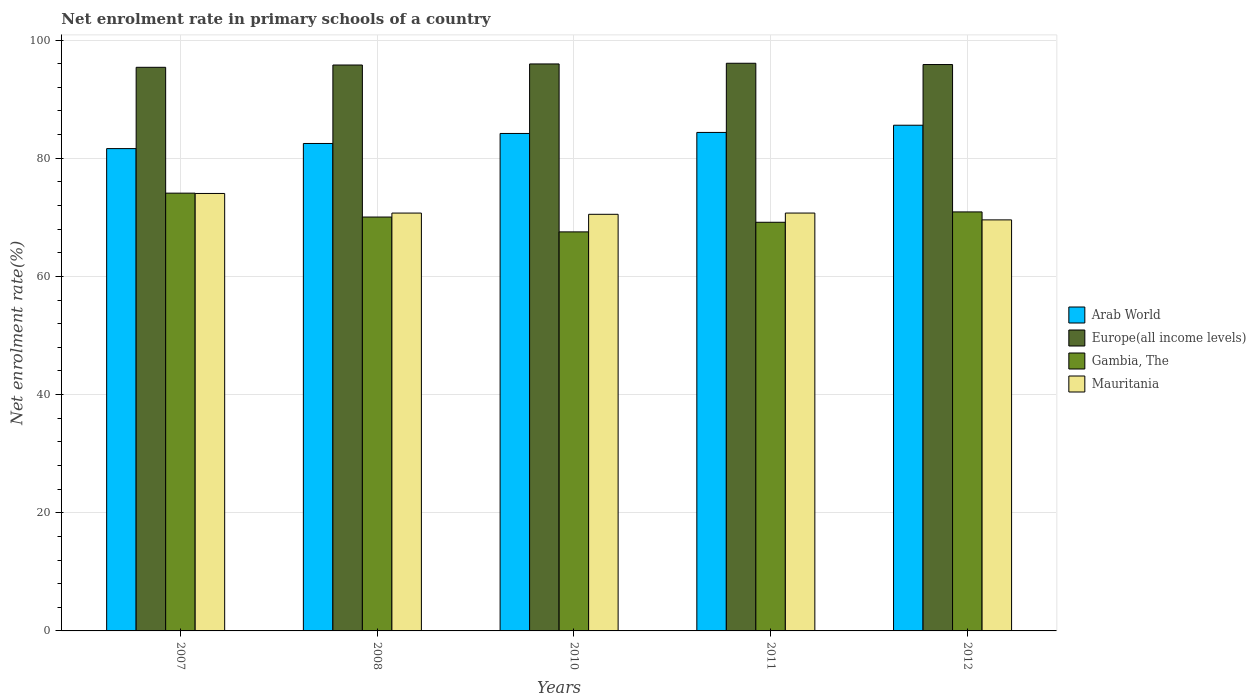How many different coloured bars are there?
Your answer should be compact. 4. How many groups of bars are there?
Your answer should be very brief. 5. Are the number of bars on each tick of the X-axis equal?
Give a very brief answer. Yes. How many bars are there on the 5th tick from the left?
Your answer should be compact. 4. How many bars are there on the 4th tick from the right?
Provide a succinct answer. 4. What is the net enrolment rate in primary schools in Mauritania in 2012?
Your answer should be very brief. 69.56. Across all years, what is the maximum net enrolment rate in primary schools in Gambia, The?
Give a very brief answer. 74.09. Across all years, what is the minimum net enrolment rate in primary schools in Arab World?
Provide a short and direct response. 81.63. In which year was the net enrolment rate in primary schools in Mauritania minimum?
Offer a terse response. 2012. What is the total net enrolment rate in primary schools in Europe(all income levels) in the graph?
Give a very brief answer. 479.04. What is the difference between the net enrolment rate in primary schools in Europe(all income levels) in 2011 and that in 2012?
Give a very brief answer. 0.22. What is the difference between the net enrolment rate in primary schools in Mauritania in 2007 and the net enrolment rate in primary schools in Gambia, The in 2010?
Give a very brief answer. 6.5. What is the average net enrolment rate in primary schools in Mauritania per year?
Your answer should be compact. 71.11. In the year 2011, what is the difference between the net enrolment rate in primary schools in Mauritania and net enrolment rate in primary schools in Europe(all income levels)?
Ensure brevity in your answer.  -25.35. What is the ratio of the net enrolment rate in primary schools in Mauritania in 2010 to that in 2011?
Offer a very short reply. 1. Is the difference between the net enrolment rate in primary schools in Mauritania in 2008 and 2010 greater than the difference between the net enrolment rate in primary schools in Europe(all income levels) in 2008 and 2010?
Your answer should be very brief. Yes. What is the difference between the highest and the second highest net enrolment rate in primary schools in Mauritania?
Ensure brevity in your answer.  3.32. What is the difference between the highest and the lowest net enrolment rate in primary schools in Mauritania?
Provide a succinct answer. 4.47. Is it the case that in every year, the sum of the net enrolment rate in primary schools in Arab World and net enrolment rate in primary schools in Gambia, The is greater than the sum of net enrolment rate in primary schools in Europe(all income levels) and net enrolment rate in primary schools in Mauritania?
Ensure brevity in your answer.  No. What does the 3rd bar from the left in 2010 represents?
Keep it short and to the point. Gambia, The. What does the 2nd bar from the right in 2010 represents?
Your answer should be compact. Gambia, The. Is it the case that in every year, the sum of the net enrolment rate in primary schools in Arab World and net enrolment rate in primary schools in Gambia, The is greater than the net enrolment rate in primary schools in Mauritania?
Ensure brevity in your answer.  Yes. How many bars are there?
Your answer should be very brief. 20. Are all the bars in the graph horizontal?
Your answer should be compact. No. How many years are there in the graph?
Make the answer very short. 5. What is the difference between two consecutive major ticks on the Y-axis?
Offer a very short reply. 20. Are the values on the major ticks of Y-axis written in scientific E-notation?
Ensure brevity in your answer.  No. Does the graph contain grids?
Offer a terse response. Yes. Where does the legend appear in the graph?
Offer a very short reply. Center right. How many legend labels are there?
Offer a terse response. 4. What is the title of the graph?
Make the answer very short. Net enrolment rate in primary schools of a country. Does "Oman" appear as one of the legend labels in the graph?
Offer a terse response. No. What is the label or title of the Y-axis?
Ensure brevity in your answer.  Net enrolment rate(%). What is the Net enrolment rate(%) in Arab World in 2007?
Make the answer very short. 81.63. What is the Net enrolment rate(%) in Europe(all income levels) in 2007?
Your answer should be compact. 95.39. What is the Net enrolment rate(%) of Gambia, The in 2007?
Ensure brevity in your answer.  74.09. What is the Net enrolment rate(%) in Mauritania in 2007?
Provide a succinct answer. 74.04. What is the Net enrolment rate(%) in Arab World in 2008?
Provide a short and direct response. 82.5. What is the Net enrolment rate(%) in Europe(all income levels) in 2008?
Your answer should be compact. 95.77. What is the Net enrolment rate(%) in Gambia, The in 2008?
Your answer should be very brief. 70.05. What is the Net enrolment rate(%) in Mauritania in 2008?
Provide a short and direct response. 70.72. What is the Net enrolment rate(%) in Arab World in 2010?
Make the answer very short. 84.19. What is the Net enrolment rate(%) in Europe(all income levels) in 2010?
Provide a short and direct response. 95.95. What is the Net enrolment rate(%) in Gambia, The in 2010?
Your answer should be very brief. 67.53. What is the Net enrolment rate(%) in Mauritania in 2010?
Your answer should be very brief. 70.51. What is the Net enrolment rate(%) of Arab World in 2011?
Provide a succinct answer. 84.36. What is the Net enrolment rate(%) of Europe(all income levels) in 2011?
Your answer should be very brief. 96.07. What is the Net enrolment rate(%) in Gambia, The in 2011?
Offer a very short reply. 69.16. What is the Net enrolment rate(%) in Mauritania in 2011?
Provide a short and direct response. 70.72. What is the Net enrolment rate(%) of Arab World in 2012?
Make the answer very short. 85.59. What is the Net enrolment rate(%) in Europe(all income levels) in 2012?
Your response must be concise. 95.85. What is the Net enrolment rate(%) of Gambia, The in 2012?
Your response must be concise. 70.91. What is the Net enrolment rate(%) in Mauritania in 2012?
Offer a very short reply. 69.56. Across all years, what is the maximum Net enrolment rate(%) of Arab World?
Keep it short and to the point. 85.59. Across all years, what is the maximum Net enrolment rate(%) of Europe(all income levels)?
Offer a very short reply. 96.07. Across all years, what is the maximum Net enrolment rate(%) in Gambia, The?
Offer a very short reply. 74.09. Across all years, what is the maximum Net enrolment rate(%) in Mauritania?
Offer a very short reply. 74.04. Across all years, what is the minimum Net enrolment rate(%) in Arab World?
Keep it short and to the point. 81.63. Across all years, what is the minimum Net enrolment rate(%) of Europe(all income levels)?
Give a very brief answer. 95.39. Across all years, what is the minimum Net enrolment rate(%) in Gambia, The?
Offer a very short reply. 67.53. Across all years, what is the minimum Net enrolment rate(%) of Mauritania?
Give a very brief answer. 69.56. What is the total Net enrolment rate(%) of Arab World in the graph?
Your answer should be compact. 418.26. What is the total Net enrolment rate(%) in Europe(all income levels) in the graph?
Your answer should be compact. 479.04. What is the total Net enrolment rate(%) in Gambia, The in the graph?
Your answer should be compact. 351.74. What is the total Net enrolment rate(%) in Mauritania in the graph?
Your answer should be very brief. 355.55. What is the difference between the Net enrolment rate(%) in Arab World in 2007 and that in 2008?
Your response must be concise. -0.87. What is the difference between the Net enrolment rate(%) of Europe(all income levels) in 2007 and that in 2008?
Provide a short and direct response. -0.39. What is the difference between the Net enrolment rate(%) in Gambia, The in 2007 and that in 2008?
Keep it short and to the point. 4.04. What is the difference between the Net enrolment rate(%) of Mauritania in 2007 and that in 2008?
Your answer should be compact. 3.32. What is the difference between the Net enrolment rate(%) in Arab World in 2007 and that in 2010?
Give a very brief answer. -2.56. What is the difference between the Net enrolment rate(%) of Europe(all income levels) in 2007 and that in 2010?
Your answer should be very brief. -0.57. What is the difference between the Net enrolment rate(%) in Gambia, The in 2007 and that in 2010?
Provide a succinct answer. 6.56. What is the difference between the Net enrolment rate(%) in Mauritania in 2007 and that in 2010?
Give a very brief answer. 3.53. What is the difference between the Net enrolment rate(%) in Arab World in 2007 and that in 2011?
Keep it short and to the point. -2.74. What is the difference between the Net enrolment rate(%) of Europe(all income levels) in 2007 and that in 2011?
Offer a terse response. -0.68. What is the difference between the Net enrolment rate(%) in Gambia, The in 2007 and that in 2011?
Offer a very short reply. 4.93. What is the difference between the Net enrolment rate(%) of Mauritania in 2007 and that in 2011?
Offer a very short reply. 3.32. What is the difference between the Net enrolment rate(%) of Arab World in 2007 and that in 2012?
Your response must be concise. -3.96. What is the difference between the Net enrolment rate(%) in Europe(all income levels) in 2007 and that in 2012?
Your answer should be very brief. -0.47. What is the difference between the Net enrolment rate(%) in Gambia, The in 2007 and that in 2012?
Your response must be concise. 3.18. What is the difference between the Net enrolment rate(%) in Mauritania in 2007 and that in 2012?
Ensure brevity in your answer.  4.47. What is the difference between the Net enrolment rate(%) in Arab World in 2008 and that in 2010?
Your answer should be compact. -1.69. What is the difference between the Net enrolment rate(%) of Europe(all income levels) in 2008 and that in 2010?
Provide a short and direct response. -0.18. What is the difference between the Net enrolment rate(%) in Gambia, The in 2008 and that in 2010?
Your answer should be very brief. 2.51. What is the difference between the Net enrolment rate(%) of Mauritania in 2008 and that in 2010?
Provide a short and direct response. 0.21. What is the difference between the Net enrolment rate(%) in Arab World in 2008 and that in 2011?
Your answer should be very brief. -1.87. What is the difference between the Net enrolment rate(%) in Europe(all income levels) in 2008 and that in 2011?
Your response must be concise. -0.3. What is the difference between the Net enrolment rate(%) of Gambia, The in 2008 and that in 2011?
Offer a terse response. 0.89. What is the difference between the Net enrolment rate(%) of Mauritania in 2008 and that in 2011?
Your answer should be compact. -0. What is the difference between the Net enrolment rate(%) in Arab World in 2008 and that in 2012?
Offer a terse response. -3.09. What is the difference between the Net enrolment rate(%) in Europe(all income levels) in 2008 and that in 2012?
Offer a very short reply. -0.08. What is the difference between the Net enrolment rate(%) of Gambia, The in 2008 and that in 2012?
Your answer should be very brief. -0.87. What is the difference between the Net enrolment rate(%) of Mauritania in 2008 and that in 2012?
Keep it short and to the point. 1.15. What is the difference between the Net enrolment rate(%) of Arab World in 2010 and that in 2011?
Provide a short and direct response. -0.17. What is the difference between the Net enrolment rate(%) in Europe(all income levels) in 2010 and that in 2011?
Your answer should be very brief. -0.12. What is the difference between the Net enrolment rate(%) of Gambia, The in 2010 and that in 2011?
Your answer should be compact. -1.63. What is the difference between the Net enrolment rate(%) of Mauritania in 2010 and that in 2011?
Provide a succinct answer. -0.21. What is the difference between the Net enrolment rate(%) in Arab World in 2010 and that in 2012?
Make the answer very short. -1.4. What is the difference between the Net enrolment rate(%) in Europe(all income levels) in 2010 and that in 2012?
Make the answer very short. 0.1. What is the difference between the Net enrolment rate(%) in Gambia, The in 2010 and that in 2012?
Offer a terse response. -3.38. What is the difference between the Net enrolment rate(%) of Mauritania in 2010 and that in 2012?
Offer a terse response. 0.94. What is the difference between the Net enrolment rate(%) of Arab World in 2011 and that in 2012?
Ensure brevity in your answer.  -1.22. What is the difference between the Net enrolment rate(%) in Europe(all income levels) in 2011 and that in 2012?
Offer a terse response. 0.22. What is the difference between the Net enrolment rate(%) in Gambia, The in 2011 and that in 2012?
Offer a very short reply. -1.75. What is the difference between the Net enrolment rate(%) in Mauritania in 2011 and that in 2012?
Give a very brief answer. 1.15. What is the difference between the Net enrolment rate(%) in Arab World in 2007 and the Net enrolment rate(%) in Europe(all income levels) in 2008?
Provide a short and direct response. -14.15. What is the difference between the Net enrolment rate(%) of Arab World in 2007 and the Net enrolment rate(%) of Gambia, The in 2008?
Your answer should be very brief. 11.58. What is the difference between the Net enrolment rate(%) in Arab World in 2007 and the Net enrolment rate(%) in Mauritania in 2008?
Keep it short and to the point. 10.91. What is the difference between the Net enrolment rate(%) in Europe(all income levels) in 2007 and the Net enrolment rate(%) in Gambia, The in 2008?
Give a very brief answer. 25.34. What is the difference between the Net enrolment rate(%) in Europe(all income levels) in 2007 and the Net enrolment rate(%) in Mauritania in 2008?
Make the answer very short. 24.67. What is the difference between the Net enrolment rate(%) in Gambia, The in 2007 and the Net enrolment rate(%) in Mauritania in 2008?
Provide a short and direct response. 3.37. What is the difference between the Net enrolment rate(%) of Arab World in 2007 and the Net enrolment rate(%) of Europe(all income levels) in 2010?
Offer a very short reply. -14.33. What is the difference between the Net enrolment rate(%) in Arab World in 2007 and the Net enrolment rate(%) in Gambia, The in 2010?
Offer a very short reply. 14.09. What is the difference between the Net enrolment rate(%) in Arab World in 2007 and the Net enrolment rate(%) in Mauritania in 2010?
Your answer should be very brief. 11.12. What is the difference between the Net enrolment rate(%) of Europe(all income levels) in 2007 and the Net enrolment rate(%) of Gambia, The in 2010?
Provide a succinct answer. 27.86. What is the difference between the Net enrolment rate(%) in Europe(all income levels) in 2007 and the Net enrolment rate(%) in Mauritania in 2010?
Ensure brevity in your answer.  24.88. What is the difference between the Net enrolment rate(%) in Gambia, The in 2007 and the Net enrolment rate(%) in Mauritania in 2010?
Your response must be concise. 3.58. What is the difference between the Net enrolment rate(%) in Arab World in 2007 and the Net enrolment rate(%) in Europe(all income levels) in 2011?
Your answer should be compact. -14.44. What is the difference between the Net enrolment rate(%) of Arab World in 2007 and the Net enrolment rate(%) of Gambia, The in 2011?
Offer a very short reply. 12.47. What is the difference between the Net enrolment rate(%) of Arab World in 2007 and the Net enrolment rate(%) of Mauritania in 2011?
Provide a short and direct response. 10.91. What is the difference between the Net enrolment rate(%) in Europe(all income levels) in 2007 and the Net enrolment rate(%) in Gambia, The in 2011?
Provide a short and direct response. 26.23. What is the difference between the Net enrolment rate(%) in Europe(all income levels) in 2007 and the Net enrolment rate(%) in Mauritania in 2011?
Ensure brevity in your answer.  24.67. What is the difference between the Net enrolment rate(%) in Gambia, The in 2007 and the Net enrolment rate(%) in Mauritania in 2011?
Make the answer very short. 3.37. What is the difference between the Net enrolment rate(%) of Arab World in 2007 and the Net enrolment rate(%) of Europe(all income levels) in 2012?
Your answer should be very brief. -14.23. What is the difference between the Net enrolment rate(%) of Arab World in 2007 and the Net enrolment rate(%) of Gambia, The in 2012?
Provide a succinct answer. 10.71. What is the difference between the Net enrolment rate(%) in Arab World in 2007 and the Net enrolment rate(%) in Mauritania in 2012?
Offer a terse response. 12.06. What is the difference between the Net enrolment rate(%) of Europe(all income levels) in 2007 and the Net enrolment rate(%) of Gambia, The in 2012?
Ensure brevity in your answer.  24.48. What is the difference between the Net enrolment rate(%) of Europe(all income levels) in 2007 and the Net enrolment rate(%) of Mauritania in 2012?
Keep it short and to the point. 25.82. What is the difference between the Net enrolment rate(%) of Gambia, The in 2007 and the Net enrolment rate(%) of Mauritania in 2012?
Your response must be concise. 4.53. What is the difference between the Net enrolment rate(%) in Arab World in 2008 and the Net enrolment rate(%) in Europe(all income levels) in 2010?
Your answer should be compact. -13.46. What is the difference between the Net enrolment rate(%) in Arab World in 2008 and the Net enrolment rate(%) in Gambia, The in 2010?
Give a very brief answer. 14.96. What is the difference between the Net enrolment rate(%) of Arab World in 2008 and the Net enrolment rate(%) of Mauritania in 2010?
Your response must be concise. 11.99. What is the difference between the Net enrolment rate(%) in Europe(all income levels) in 2008 and the Net enrolment rate(%) in Gambia, The in 2010?
Keep it short and to the point. 28.24. What is the difference between the Net enrolment rate(%) of Europe(all income levels) in 2008 and the Net enrolment rate(%) of Mauritania in 2010?
Ensure brevity in your answer.  25.27. What is the difference between the Net enrolment rate(%) in Gambia, The in 2008 and the Net enrolment rate(%) in Mauritania in 2010?
Your answer should be very brief. -0.46. What is the difference between the Net enrolment rate(%) of Arab World in 2008 and the Net enrolment rate(%) of Europe(all income levels) in 2011?
Offer a very short reply. -13.58. What is the difference between the Net enrolment rate(%) in Arab World in 2008 and the Net enrolment rate(%) in Gambia, The in 2011?
Give a very brief answer. 13.34. What is the difference between the Net enrolment rate(%) of Arab World in 2008 and the Net enrolment rate(%) of Mauritania in 2011?
Your response must be concise. 11.78. What is the difference between the Net enrolment rate(%) in Europe(all income levels) in 2008 and the Net enrolment rate(%) in Gambia, The in 2011?
Provide a short and direct response. 26.62. What is the difference between the Net enrolment rate(%) in Europe(all income levels) in 2008 and the Net enrolment rate(%) in Mauritania in 2011?
Your response must be concise. 25.06. What is the difference between the Net enrolment rate(%) of Gambia, The in 2008 and the Net enrolment rate(%) of Mauritania in 2011?
Offer a terse response. -0.67. What is the difference between the Net enrolment rate(%) of Arab World in 2008 and the Net enrolment rate(%) of Europe(all income levels) in 2012?
Ensure brevity in your answer.  -13.36. What is the difference between the Net enrolment rate(%) of Arab World in 2008 and the Net enrolment rate(%) of Gambia, The in 2012?
Provide a succinct answer. 11.58. What is the difference between the Net enrolment rate(%) in Arab World in 2008 and the Net enrolment rate(%) in Mauritania in 2012?
Ensure brevity in your answer.  12.93. What is the difference between the Net enrolment rate(%) of Europe(all income levels) in 2008 and the Net enrolment rate(%) of Gambia, The in 2012?
Provide a succinct answer. 24.86. What is the difference between the Net enrolment rate(%) in Europe(all income levels) in 2008 and the Net enrolment rate(%) in Mauritania in 2012?
Your response must be concise. 26.21. What is the difference between the Net enrolment rate(%) of Gambia, The in 2008 and the Net enrolment rate(%) of Mauritania in 2012?
Make the answer very short. 0.48. What is the difference between the Net enrolment rate(%) in Arab World in 2010 and the Net enrolment rate(%) in Europe(all income levels) in 2011?
Your response must be concise. -11.88. What is the difference between the Net enrolment rate(%) of Arab World in 2010 and the Net enrolment rate(%) of Gambia, The in 2011?
Keep it short and to the point. 15.03. What is the difference between the Net enrolment rate(%) in Arab World in 2010 and the Net enrolment rate(%) in Mauritania in 2011?
Provide a succinct answer. 13.47. What is the difference between the Net enrolment rate(%) of Europe(all income levels) in 2010 and the Net enrolment rate(%) of Gambia, The in 2011?
Your answer should be very brief. 26.8. What is the difference between the Net enrolment rate(%) of Europe(all income levels) in 2010 and the Net enrolment rate(%) of Mauritania in 2011?
Make the answer very short. 25.24. What is the difference between the Net enrolment rate(%) of Gambia, The in 2010 and the Net enrolment rate(%) of Mauritania in 2011?
Your answer should be very brief. -3.19. What is the difference between the Net enrolment rate(%) of Arab World in 2010 and the Net enrolment rate(%) of Europe(all income levels) in 2012?
Offer a very short reply. -11.66. What is the difference between the Net enrolment rate(%) in Arab World in 2010 and the Net enrolment rate(%) in Gambia, The in 2012?
Make the answer very short. 13.28. What is the difference between the Net enrolment rate(%) in Arab World in 2010 and the Net enrolment rate(%) in Mauritania in 2012?
Provide a succinct answer. 14.63. What is the difference between the Net enrolment rate(%) in Europe(all income levels) in 2010 and the Net enrolment rate(%) in Gambia, The in 2012?
Make the answer very short. 25.04. What is the difference between the Net enrolment rate(%) in Europe(all income levels) in 2010 and the Net enrolment rate(%) in Mauritania in 2012?
Make the answer very short. 26.39. What is the difference between the Net enrolment rate(%) of Gambia, The in 2010 and the Net enrolment rate(%) of Mauritania in 2012?
Keep it short and to the point. -2.03. What is the difference between the Net enrolment rate(%) in Arab World in 2011 and the Net enrolment rate(%) in Europe(all income levels) in 2012?
Give a very brief answer. -11.49. What is the difference between the Net enrolment rate(%) of Arab World in 2011 and the Net enrolment rate(%) of Gambia, The in 2012?
Offer a terse response. 13.45. What is the difference between the Net enrolment rate(%) of Arab World in 2011 and the Net enrolment rate(%) of Mauritania in 2012?
Your answer should be compact. 14.8. What is the difference between the Net enrolment rate(%) in Europe(all income levels) in 2011 and the Net enrolment rate(%) in Gambia, The in 2012?
Make the answer very short. 25.16. What is the difference between the Net enrolment rate(%) in Europe(all income levels) in 2011 and the Net enrolment rate(%) in Mauritania in 2012?
Offer a terse response. 26.51. What is the difference between the Net enrolment rate(%) of Gambia, The in 2011 and the Net enrolment rate(%) of Mauritania in 2012?
Provide a short and direct response. -0.41. What is the average Net enrolment rate(%) in Arab World per year?
Ensure brevity in your answer.  83.65. What is the average Net enrolment rate(%) of Europe(all income levels) per year?
Give a very brief answer. 95.81. What is the average Net enrolment rate(%) of Gambia, The per year?
Your response must be concise. 70.35. What is the average Net enrolment rate(%) in Mauritania per year?
Offer a terse response. 71.11. In the year 2007, what is the difference between the Net enrolment rate(%) of Arab World and Net enrolment rate(%) of Europe(all income levels)?
Provide a short and direct response. -13.76. In the year 2007, what is the difference between the Net enrolment rate(%) in Arab World and Net enrolment rate(%) in Gambia, The?
Your answer should be compact. 7.54. In the year 2007, what is the difference between the Net enrolment rate(%) in Arab World and Net enrolment rate(%) in Mauritania?
Keep it short and to the point. 7.59. In the year 2007, what is the difference between the Net enrolment rate(%) in Europe(all income levels) and Net enrolment rate(%) in Gambia, The?
Your answer should be very brief. 21.3. In the year 2007, what is the difference between the Net enrolment rate(%) of Europe(all income levels) and Net enrolment rate(%) of Mauritania?
Your answer should be very brief. 21.35. In the year 2007, what is the difference between the Net enrolment rate(%) of Gambia, The and Net enrolment rate(%) of Mauritania?
Keep it short and to the point. 0.05. In the year 2008, what is the difference between the Net enrolment rate(%) in Arab World and Net enrolment rate(%) in Europe(all income levels)?
Keep it short and to the point. -13.28. In the year 2008, what is the difference between the Net enrolment rate(%) of Arab World and Net enrolment rate(%) of Gambia, The?
Provide a succinct answer. 12.45. In the year 2008, what is the difference between the Net enrolment rate(%) of Arab World and Net enrolment rate(%) of Mauritania?
Make the answer very short. 11.78. In the year 2008, what is the difference between the Net enrolment rate(%) of Europe(all income levels) and Net enrolment rate(%) of Gambia, The?
Ensure brevity in your answer.  25.73. In the year 2008, what is the difference between the Net enrolment rate(%) of Europe(all income levels) and Net enrolment rate(%) of Mauritania?
Keep it short and to the point. 25.06. In the year 2008, what is the difference between the Net enrolment rate(%) in Gambia, The and Net enrolment rate(%) in Mauritania?
Offer a very short reply. -0.67. In the year 2010, what is the difference between the Net enrolment rate(%) in Arab World and Net enrolment rate(%) in Europe(all income levels)?
Make the answer very short. -11.77. In the year 2010, what is the difference between the Net enrolment rate(%) in Arab World and Net enrolment rate(%) in Gambia, The?
Offer a terse response. 16.66. In the year 2010, what is the difference between the Net enrolment rate(%) in Arab World and Net enrolment rate(%) in Mauritania?
Provide a succinct answer. 13.68. In the year 2010, what is the difference between the Net enrolment rate(%) in Europe(all income levels) and Net enrolment rate(%) in Gambia, The?
Your response must be concise. 28.42. In the year 2010, what is the difference between the Net enrolment rate(%) of Europe(all income levels) and Net enrolment rate(%) of Mauritania?
Provide a succinct answer. 25.45. In the year 2010, what is the difference between the Net enrolment rate(%) in Gambia, The and Net enrolment rate(%) in Mauritania?
Your answer should be compact. -2.98. In the year 2011, what is the difference between the Net enrolment rate(%) of Arab World and Net enrolment rate(%) of Europe(all income levels)?
Offer a terse response. -11.71. In the year 2011, what is the difference between the Net enrolment rate(%) in Arab World and Net enrolment rate(%) in Gambia, The?
Make the answer very short. 15.21. In the year 2011, what is the difference between the Net enrolment rate(%) in Arab World and Net enrolment rate(%) in Mauritania?
Give a very brief answer. 13.65. In the year 2011, what is the difference between the Net enrolment rate(%) in Europe(all income levels) and Net enrolment rate(%) in Gambia, The?
Provide a short and direct response. 26.91. In the year 2011, what is the difference between the Net enrolment rate(%) in Europe(all income levels) and Net enrolment rate(%) in Mauritania?
Your answer should be very brief. 25.35. In the year 2011, what is the difference between the Net enrolment rate(%) in Gambia, The and Net enrolment rate(%) in Mauritania?
Your answer should be compact. -1.56. In the year 2012, what is the difference between the Net enrolment rate(%) in Arab World and Net enrolment rate(%) in Europe(all income levels)?
Keep it short and to the point. -10.27. In the year 2012, what is the difference between the Net enrolment rate(%) in Arab World and Net enrolment rate(%) in Gambia, The?
Your answer should be very brief. 14.67. In the year 2012, what is the difference between the Net enrolment rate(%) in Arab World and Net enrolment rate(%) in Mauritania?
Your answer should be very brief. 16.02. In the year 2012, what is the difference between the Net enrolment rate(%) of Europe(all income levels) and Net enrolment rate(%) of Gambia, The?
Give a very brief answer. 24.94. In the year 2012, what is the difference between the Net enrolment rate(%) of Europe(all income levels) and Net enrolment rate(%) of Mauritania?
Your response must be concise. 26.29. In the year 2012, what is the difference between the Net enrolment rate(%) in Gambia, The and Net enrolment rate(%) in Mauritania?
Make the answer very short. 1.35. What is the ratio of the Net enrolment rate(%) of Europe(all income levels) in 2007 to that in 2008?
Ensure brevity in your answer.  1. What is the ratio of the Net enrolment rate(%) in Gambia, The in 2007 to that in 2008?
Provide a succinct answer. 1.06. What is the ratio of the Net enrolment rate(%) of Mauritania in 2007 to that in 2008?
Provide a succinct answer. 1.05. What is the ratio of the Net enrolment rate(%) of Arab World in 2007 to that in 2010?
Offer a terse response. 0.97. What is the ratio of the Net enrolment rate(%) in Europe(all income levels) in 2007 to that in 2010?
Offer a terse response. 0.99. What is the ratio of the Net enrolment rate(%) in Gambia, The in 2007 to that in 2010?
Keep it short and to the point. 1.1. What is the ratio of the Net enrolment rate(%) in Arab World in 2007 to that in 2011?
Your answer should be compact. 0.97. What is the ratio of the Net enrolment rate(%) in Europe(all income levels) in 2007 to that in 2011?
Keep it short and to the point. 0.99. What is the ratio of the Net enrolment rate(%) in Gambia, The in 2007 to that in 2011?
Your answer should be compact. 1.07. What is the ratio of the Net enrolment rate(%) in Mauritania in 2007 to that in 2011?
Give a very brief answer. 1.05. What is the ratio of the Net enrolment rate(%) in Arab World in 2007 to that in 2012?
Provide a short and direct response. 0.95. What is the ratio of the Net enrolment rate(%) in Europe(all income levels) in 2007 to that in 2012?
Give a very brief answer. 1. What is the ratio of the Net enrolment rate(%) of Gambia, The in 2007 to that in 2012?
Your response must be concise. 1.04. What is the ratio of the Net enrolment rate(%) of Mauritania in 2007 to that in 2012?
Your answer should be very brief. 1.06. What is the ratio of the Net enrolment rate(%) in Arab World in 2008 to that in 2010?
Your answer should be very brief. 0.98. What is the ratio of the Net enrolment rate(%) of Gambia, The in 2008 to that in 2010?
Your response must be concise. 1.04. What is the ratio of the Net enrolment rate(%) of Mauritania in 2008 to that in 2010?
Give a very brief answer. 1. What is the ratio of the Net enrolment rate(%) in Arab World in 2008 to that in 2011?
Provide a short and direct response. 0.98. What is the ratio of the Net enrolment rate(%) in Europe(all income levels) in 2008 to that in 2011?
Your response must be concise. 1. What is the ratio of the Net enrolment rate(%) of Gambia, The in 2008 to that in 2011?
Your answer should be compact. 1.01. What is the ratio of the Net enrolment rate(%) in Mauritania in 2008 to that in 2011?
Provide a short and direct response. 1. What is the ratio of the Net enrolment rate(%) of Arab World in 2008 to that in 2012?
Keep it short and to the point. 0.96. What is the ratio of the Net enrolment rate(%) in Gambia, The in 2008 to that in 2012?
Your answer should be compact. 0.99. What is the ratio of the Net enrolment rate(%) in Mauritania in 2008 to that in 2012?
Provide a short and direct response. 1.02. What is the ratio of the Net enrolment rate(%) in Arab World in 2010 to that in 2011?
Ensure brevity in your answer.  1. What is the ratio of the Net enrolment rate(%) of Gambia, The in 2010 to that in 2011?
Your answer should be compact. 0.98. What is the ratio of the Net enrolment rate(%) in Mauritania in 2010 to that in 2011?
Offer a terse response. 1. What is the ratio of the Net enrolment rate(%) of Arab World in 2010 to that in 2012?
Keep it short and to the point. 0.98. What is the ratio of the Net enrolment rate(%) in Europe(all income levels) in 2010 to that in 2012?
Keep it short and to the point. 1. What is the ratio of the Net enrolment rate(%) in Gambia, The in 2010 to that in 2012?
Make the answer very short. 0.95. What is the ratio of the Net enrolment rate(%) in Mauritania in 2010 to that in 2012?
Your answer should be very brief. 1.01. What is the ratio of the Net enrolment rate(%) of Arab World in 2011 to that in 2012?
Offer a very short reply. 0.99. What is the ratio of the Net enrolment rate(%) of Gambia, The in 2011 to that in 2012?
Your answer should be compact. 0.98. What is the ratio of the Net enrolment rate(%) in Mauritania in 2011 to that in 2012?
Offer a terse response. 1.02. What is the difference between the highest and the second highest Net enrolment rate(%) of Arab World?
Provide a succinct answer. 1.22. What is the difference between the highest and the second highest Net enrolment rate(%) of Europe(all income levels)?
Give a very brief answer. 0.12. What is the difference between the highest and the second highest Net enrolment rate(%) of Gambia, The?
Offer a very short reply. 3.18. What is the difference between the highest and the second highest Net enrolment rate(%) in Mauritania?
Provide a succinct answer. 3.32. What is the difference between the highest and the lowest Net enrolment rate(%) of Arab World?
Keep it short and to the point. 3.96. What is the difference between the highest and the lowest Net enrolment rate(%) in Europe(all income levels)?
Your answer should be very brief. 0.68. What is the difference between the highest and the lowest Net enrolment rate(%) of Gambia, The?
Your answer should be very brief. 6.56. What is the difference between the highest and the lowest Net enrolment rate(%) of Mauritania?
Provide a succinct answer. 4.47. 